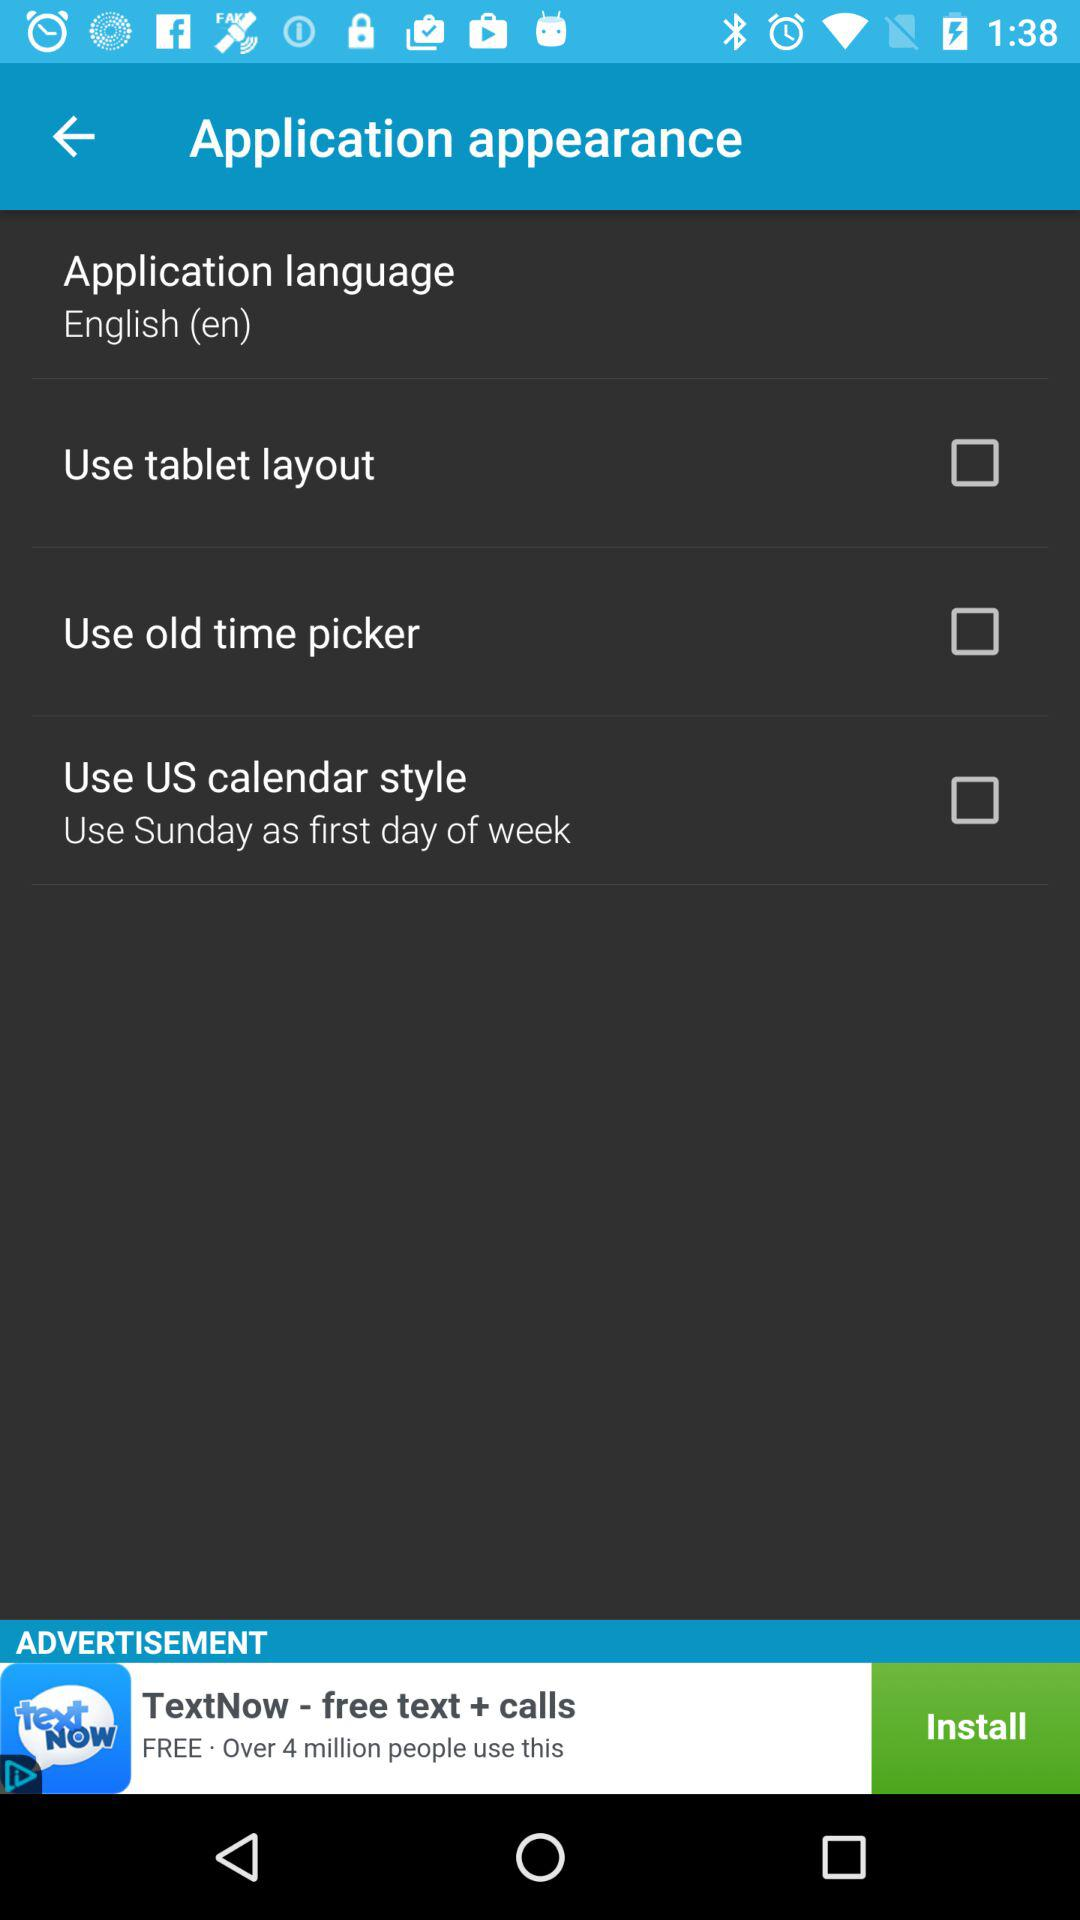What is the status of "Use old time picker"? The status is "off". 